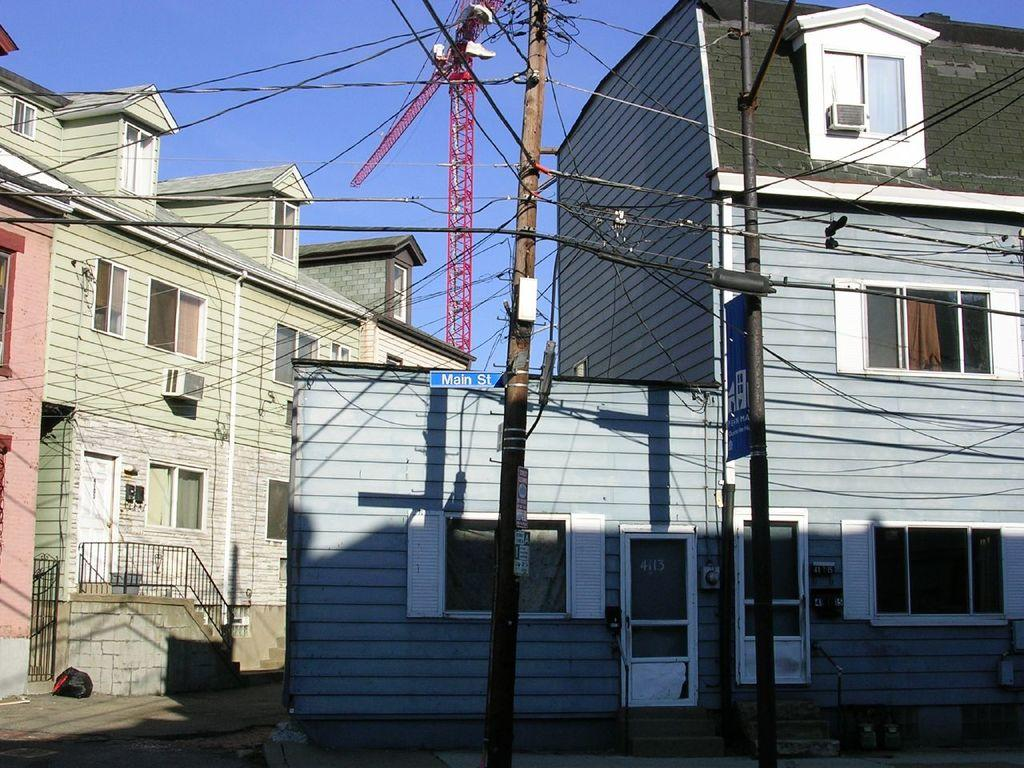What type of structures can be seen in the image? There are buildings in the image. What feature is present that might be used for safety or support? There is a railing in the image. What parts of the buildings allow access or entry? There are doors in the image. What architectural elements provide light and ventilation? There are windows in the image. What objects might be related to communication or information sharing? There are current polls in the image. What might be used for transmitting power or data? There are cables in the image. What materials are present that might be used for displaying information or advertisements? There are boards in the image. What is the color of the sky in the image? The sky is blue in the image. Can you see any fish swimming in the image? There are no fish present in the image. What type of collar is being worn by the person in the image? There are no people or collars present in the image. 